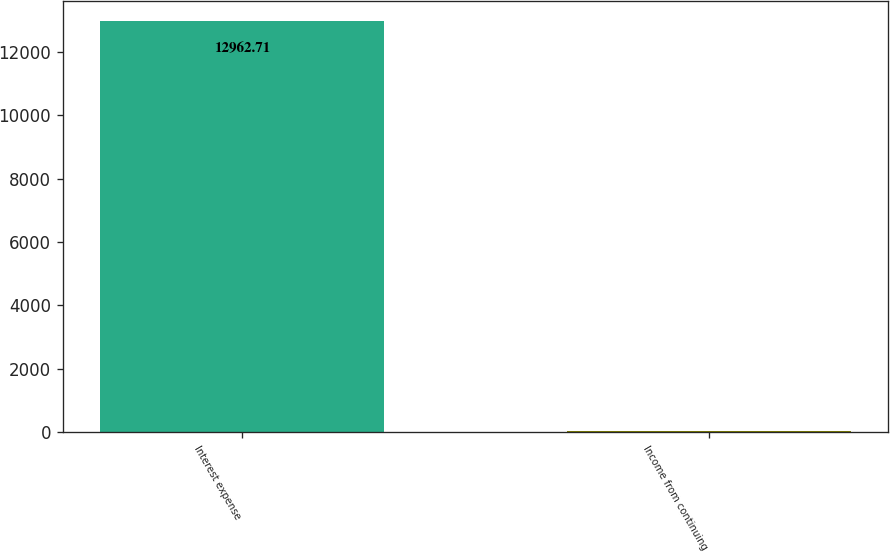<chart> <loc_0><loc_0><loc_500><loc_500><bar_chart><fcel>Interest expense<fcel>Income from continuing<nl><fcel>12962.7<fcel>23.01<nl></chart> 